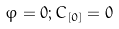Convert formula to latex. <formula><loc_0><loc_0><loc_500><loc_500>\varphi = 0 ; C _ { [ 0 ] } = 0</formula> 